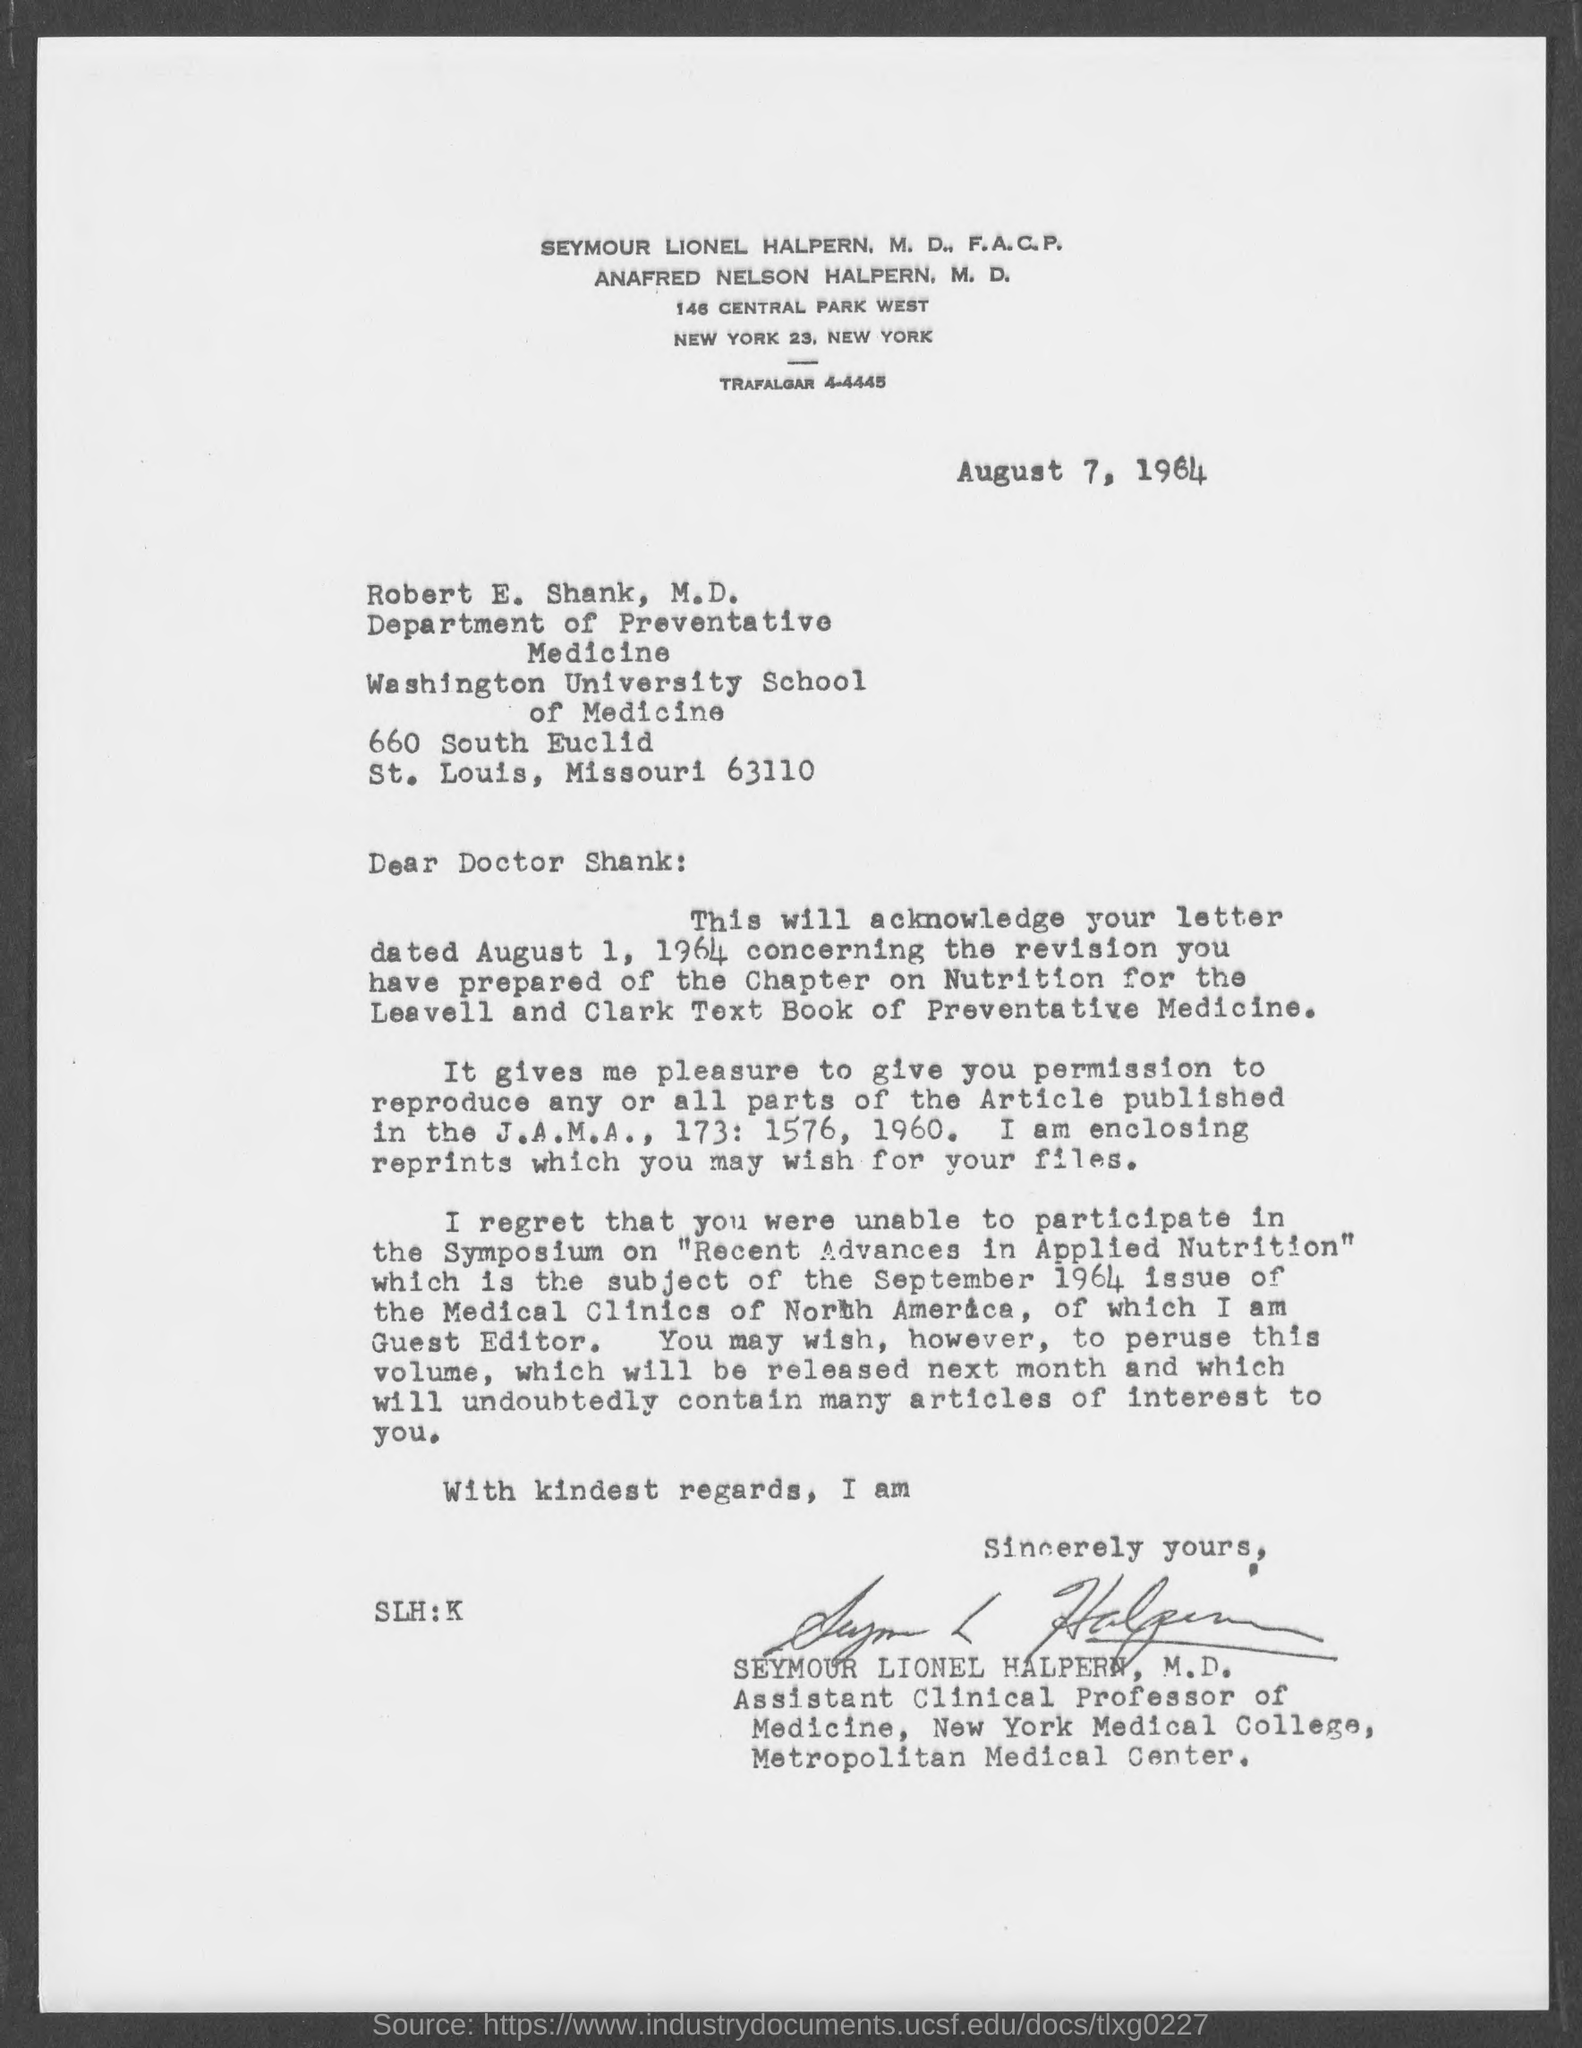Who wrote this letter?
Give a very brief answer. Seymour Lionel Halpern, M.D. 